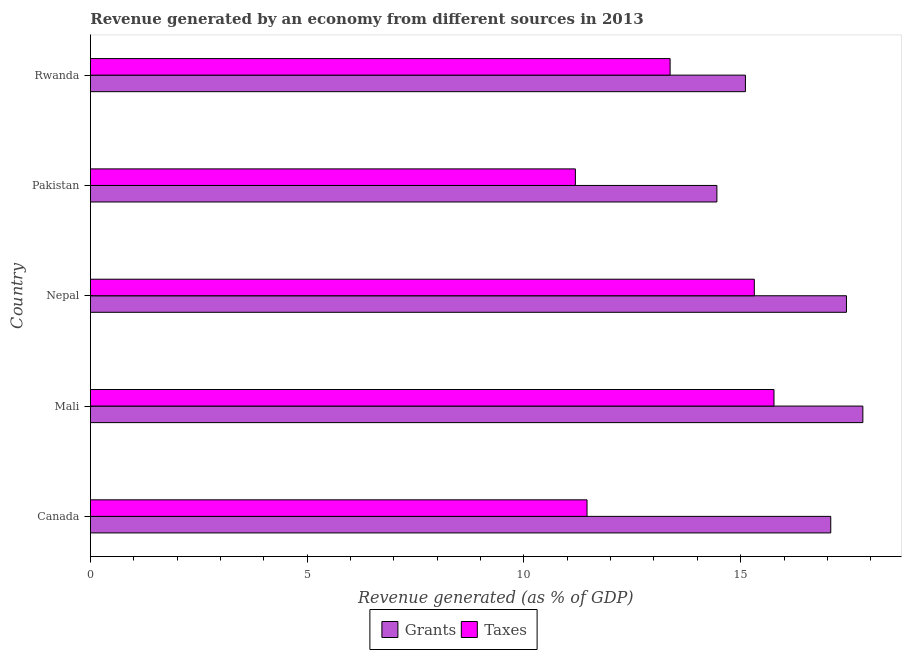How many different coloured bars are there?
Give a very brief answer. 2. How many groups of bars are there?
Offer a very short reply. 5. Are the number of bars per tick equal to the number of legend labels?
Provide a short and direct response. Yes. Are the number of bars on each tick of the Y-axis equal?
Offer a terse response. Yes. How many bars are there on the 3rd tick from the top?
Provide a short and direct response. 2. How many bars are there on the 5th tick from the bottom?
Ensure brevity in your answer.  2. What is the label of the 4th group of bars from the top?
Ensure brevity in your answer.  Mali. In how many cases, is the number of bars for a given country not equal to the number of legend labels?
Keep it short and to the point. 0. What is the revenue generated by taxes in Pakistan?
Offer a very short reply. 11.19. Across all countries, what is the maximum revenue generated by grants?
Provide a succinct answer. 17.82. Across all countries, what is the minimum revenue generated by taxes?
Offer a terse response. 11.19. In which country was the revenue generated by taxes maximum?
Offer a very short reply. Mali. What is the total revenue generated by taxes in the graph?
Offer a very short reply. 67.1. What is the difference between the revenue generated by grants in Canada and that in Mali?
Your answer should be very brief. -0.74. What is the difference between the revenue generated by taxes in Mali and the revenue generated by grants in Nepal?
Offer a terse response. -1.67. What is the average revenue generated by grants per country?
Offer a very short reply. 16.38. What is the difference between the revenue generated by taxes and revenue generated by grants in Mali?
Offer a very short reply. -2.05. In how many countries, is the revenue generated by taxes greater than 17 %?
Ensure brevity in your answer.  0. What is the ratio of the revenue generated by grants in Canada to that in Mali?
Your answer should be compact. 0.96. Is the revenue generated by taxes in Canada less than that in Mali?
Ensure brevity in your answer.  Yes. What is the difference between the highest and the second highest revenue generated by grants?
Provide a short and direct response. 0.38. What is the difference between the highest and the lowest revenue generated by taxes?
Provide a succinct answer. 4.58. In how many countries, is the revenue generated by grants greater than the average revenue generated by grants taken over all countries?
Your response must be concise. 3. Is the sum of the revenue generated by grants in Canada and Rwanda greater than the maximum revenue generated by taxes across all countries?
Keep it short and to the point. Yes. What does the 1st bar from the top in Pakistan represents?
Make the answer very short. Taxes. What does the 1st bar from the bottom in Pakistan represents?
Provide a succinct answer. Grants. How many countries are there in the graph?
Provide a short and direct response. 5. What is the difference between two consecutive major ticks on the X-axis?
Your answer should be compact. 5. How are the legend labels stacked?
Offer a very short reply. Horizontal. What is the title of the graph?
Provide a succinct answer. Revenue generated by an economy from different sources in 2013. What is the label or title of the X-axis?
Keep it short and to the point. Revenue generated (as % of GDP). What is the Revenue generated (as % of GDP) in Grants in Canada?
Offer a terse response. 17.08. What is the Revenue generated (as % of GDP) in Taxes in Canada?
Ensure brevity in your answer.  11.46. What is the Revenue generated (as % of GDP) in Grants in Mali?
Give a very brief answer. 17.82. What is the Revenue generated (as % of GDP) in Taxes in Mali?
Keep it short and to the point. 15.77. What is the Revenue generated (as % of GDP) in Grants in Nepal?
Make the answer very short. 17.44. What is the Revenue generated (as % of GDP) in Taxes in Nepal?
Your answer should be compact. 15.31. What is the Revenue generated (as % of GDP) of Grants in Pakistan?
Make the answer very short. 14.45. What is the Revenue generated (as % of GDP) of Taxes in Pakistan?
Offer a terse response. 11.19. What is the Revenue generated (as % of GDP) of Grants in Rwanda?
Provide a short and direct response. 15.11. What is the Revenue generated (as % of GDP) in Taxes in Rwanda?
Provide a succinct answer. 13.37. Across all countries, what is the maximum Revenue generated (as % of GDP) in Grants?
Provide a short and direct response. 17.82. Across all countries, what is the maximum Revenue generated (as % of GDP) in Taxes?
Your answer should be compact. 15.77. Across all countries, what is the minimum Revenue generated (as % of GDP) in Grants?
Offer a very short reply. 14.45. Across all countries, what is the minimum Revenue generated (as % of GDP) in Taxes?
Provide a short and direct response. 11.19. What is the total Revenue generated (as % of GDP) of Grants in the graph?
Give a very brief answer. 81.89. What is the total Revenue generated (as % of GDP) in Taxes in the graph?
Your answer should be compact. 67.1. What is the difference between the Revenue generated (as % of GDP) of Grants in Canada and that in Mali?
Your answer should be compact. -0.74. What is the difference between the Revenue generated (as % of GDP) in Taxes in Canada and that in Mali?
Your answer should be compact. -4.31. What is the difference between the Revenue generated (as % of GDP) of Grants in Canada and that in Nepal?
Provide a short and direct response. -0.36. What is the difference between the Revenue generated (as % of GDP) of Taxes in Canada and that in Nepal?
Your response must be concise. -3.86. What is the difference between the Revenue generated (as % of GDP) in Grants in Canada and that in Pakistan?
Offer a very short reply. 2.63. What is the difference between the Revenue generated (as % of GDP) of Taxes in Canada and that in Pakistan?
Your answer should be very brief. 0.27. What is the difference between the Revenue generated (as % of GDP) in Grants in Canada and that in Rwanda?
Make the answer very short. 1.97. What is the difference between the Revenue generated (as % of GDP) in Taxes in Canada and that in Rwanda?
Make the answer very short. -1.92. What is the difference between the Revenue generated (as % of GDP) in Grants in Mali and that in Nepal?
Provide a succinct answer. 0.38. What is the difference between the Revenue generated (as % of GDP) in Taxes in Mali and that in Nepal?
Provide a succinct answer. 0.45. What is the difference between the Revenue generated (as % of GDP) in Grants in Mali and that in Pakistan?
Make the answer very short. 3.37. What is the difference between the Revenue generated (as % of GDP) of Taxes in Mali and that in Pakistan?
Provide a succinct answer. 4.58. What is the difference between the Revenue generated (as % of GDP) in Grants in Mali and that in Rwanda?
Make the answer very short. 2.71. What is the difference between the Revenue generated (as % of GDP) in Taxes in Mali and that in Rwanda?
Your response must be concise. 2.4. What is the difference between the Revenue generated (as % of GDP) of Grants in Nepal and that in Pakistan?
Ensure brevity in your answer.  2.99. What is the difference between the Revenue generated (as % of GDP) of Taxes in Nepal and that in Pakistan?
Make the answer very short. 4.13. What is the difference between the Revenue generated (as % of GDP) of Grants in Nepal and that in Rwanda?
Keep it short and to the point. 2.33. What is the difference between the Revenue generated (as % of GDP) of Taxes in Nepal and that in Rwanda?
Your answer should be very brief. 1.94. What is the difference between the Revenue generated (as % of GDP) of Grants in Pakistan and that in Rwanda?
Offer a terse response. -0.66. What is the difference between the Revenue generated (as % of GDP) in Taxes in Pakistan and that in Rwanda?
Ensure brevity in your answer.  -2.18. What is the difference between the Revenue generated (as % of GDP) of Grants in Canada and the Revenue generated (as % of GDP) of Taxes in Mali?
Keep it short and to the point. 1.31. What is the difference between the Revenue generated (as % of GDP) of Grants in Canada and the Revenue generated (as % of GDP) of Taxes in Nepal?
Provide a succinct answer. 1.76. What is the difference between the Revenue generated (as % of GDP) of Grants in Canada and the Revenue generated (as % of GDP) of Taxes in Pakistan?
Provide a short and direct response. 5.89. What is the difference between the Revenue generated (as % of GDP) in Grants in Canada and the Revenue generated (as % of GDP) in Taxes in Rwanda?
Offer a very short reply. 3.71. What is the difference between the Revenue generated (as % of GDP) in Grants in Mali and the Revenue generated (as % of GDP) in Taxes in Nepal?
Your response must be concise. 2.5. What is the difference between the Revenue generated (as % of GDP) of Grants in Mali and the Revenue generated (as % of GDP) of Taxes in Pakistan?
Give a very brief answer. 6.63. What is the difference between the Revenue generated (as % of GDP) of Grants in Mali and the Revenue generated (as % of GDP) of Taxes in Rwanda?
Offer a very short reply. 4.45. What is the difference between the Revenue generated (as % of GDP) of Grants in Nepal and the Revenue generated (as % of GDP) of Taxes in Pakistan?
Offer a very short reply. 6.25. What is the difference between the Revenue generated (as % of GDP) in Grants in Nepal and the Revenue generated (as % of GDP) in Taxes in Rwanda?
Give a very brief answer. 4.07. What is the difference between the Revenue generated (as % of GDP) of Grants in Pakistan and the Revenue generated (as % of GDP) of Taxes in Rwanda?
Ensure brevity in your answer.  1.08. What is the average Revenue generated (as % of GDP) in Grants per country?
Offer a terse response. 16.38. What is the average Revenue generated (as % of GDP) of Taxes per country?
Ensure brevity in your answer.  13.42. What is the difference between the Revenue generated (as % of GDP) of Grants and Revenue generated (as % of GDP) of Taxes in Canada?
Make the answer very short. 5.62. What is the difference between the Revenue generated (as % of GDP) of Grants and Revenue generated (as % of GDP) of Taxes in Mali?
Offer a very short reply. 2.05. What is the difference between the Revenue generated (as % of GDP) in Grants and Revenue generated (as % of GDP) in Taxes in Nepal?
Offer a very short reply. 2.13. What is the difference between the Revenue generated (as % of GDP) of Grants and Revenue generated (as % of GDP) of Taxes in Pakistan?
Your answer should be very brief. 3.26. What is the difference between the Revenue generated (as % of GDP) of Grants and Revenue generated (as % of GDP) of Taxes in Rwanda?
Ensure brevity in your answer.  1.74. What is the ratio of the Revenue generated (as % of GDP) of Grants in Canada to that in Mali?
Offer a very short reply. 0.96. What is the ratio of the Revenue generated (as % of GDP) of Taxes in Canada to that in Mali?
Provide a short and direct response. 0.73. What is the ratio of the Revenue generated (as % of GDP) of Grants in Canada to that in Nepal?
Make the answer very short. 0.98. What is the ratio of the Revenue generated (as % of GDP) in Taxes in Canada to that in Nepal?
Provide a succinct answer. 0.75. What is the ratio of the Revenue generated (as % of GDP) of Grants in Canada to that in Pakistan?
Your answer should be very brief. 1.18. What is the ratio of the Revenue generated (as % of GDP) in Grants in Canada to that in Rwanda?
Keep it short and to the point. 1.13. What is the ratio of the Revenue generated (as % of GDP) in Taxes in Canada to that in Rwanda?
Make the answer very short. 0.86. What is the ratio of the Revenue generated (as % of GDP) of Grants in Mali to that in Nepal?
Offer a terse response. 1.02. What is the ratio of the Revenue generated (as % of GDP) in Taxes in Mali to that in Nepal?
Make the answer very short. 1.03. What is the ratio of the Revenue generated (as % of GDP) in Grants in Mali to that in Pakistan?
Keep it short and to the point. 1.23. What is the ratio of the Revenue generated (as % of GDP) in Taxes in Mali to that in Pakistan?
Offer a terse response. 1.41. What is the ratio of the Revenue generated (as % of GDP) of Grants in Mali to that in Rwanda?
Offer a terse response. 1.18. What is the ratio of the Revenue generated (as % of GDP) in Taxes in Mali to that in Rwanda?
Make the answer very short. 1.18. What is the ratio of the Revenue generated (as % of GDP) of Grants in Nepal to that in Pakistan?
Give a very brief answer. 1.21. What is the ratio of the Revenue generated (as % of GDP) in Taxes in Nepal to that in Pakistan?
Your answer should be compact. 1.37. What is the ratio of the Revenue generated (as % of GDP) in Grants in Nepal to that in Rwanda?
Keep it short and to the point. 1.15. What is the ratio of the Revenue generated (as % of GDP) of Taxes in Nepal to that in Rwanda?
Provide a short and direct response. 1.15. What is the ratio of the Revenue generated (as % of GDP) in Grants in Pakistan to that in Rwanda?
Your response must be concise. 0.96. What is the ratio of the Revenue generated (as % of GDP) in Taxes in Pakistan to that in Rwanda?
Offer a terse response. 0.84. What is the difference between the highest and the second highest Revenue generated (as % of GDP) of Grants?
Your response must be concise. 0.38. What is the difference between the highest and the second highest Revenue generated (as % of GDP) of Taxes?
Provide a succinct answer. 0.45. What is the difference between the highest and the lowest Revenue generated (as % of GDP) in Grants?
Provide a succinct answer. 3.37. What is the difference between the highest and the lowest Revenue generated (as % of GDP) in Taxes?
Ensure brevity in your answer.  4.58. 